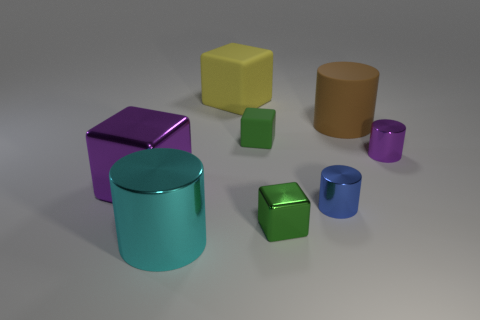Is the shape of the large thing that is on the right side of the yellow block the same as the blue metallic object? Yes, the large object on the right side of the yellow block, which appears to be a cylinder, shares the same basic cylindrical shape as the smaller blue metallic object. 